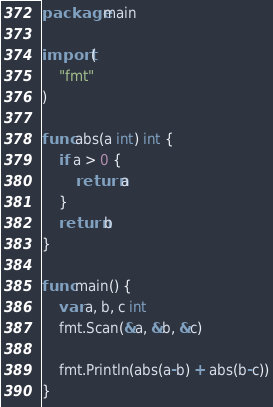<code> <loc_0><loc_0><loc_500><loc_500><_Go_>package main

import (
	"fmt"
)

func abs(a int) int {
	if a > 0 {
		return a
	}
	return b
}

func main() {
	var a, b, c int
	fmt.Scan(&a, &b, &c)

	fmt.Println(abs(a-b) + abs(b-c))
}
</code> 